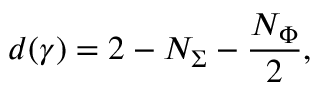<formula> <loc_0><loc_0><loc_500><loc_500>d ( \gamma ) = 2 - N _ { \Sigma } - \frac { N _ { \Phi } } { 2 } ,</formula> 